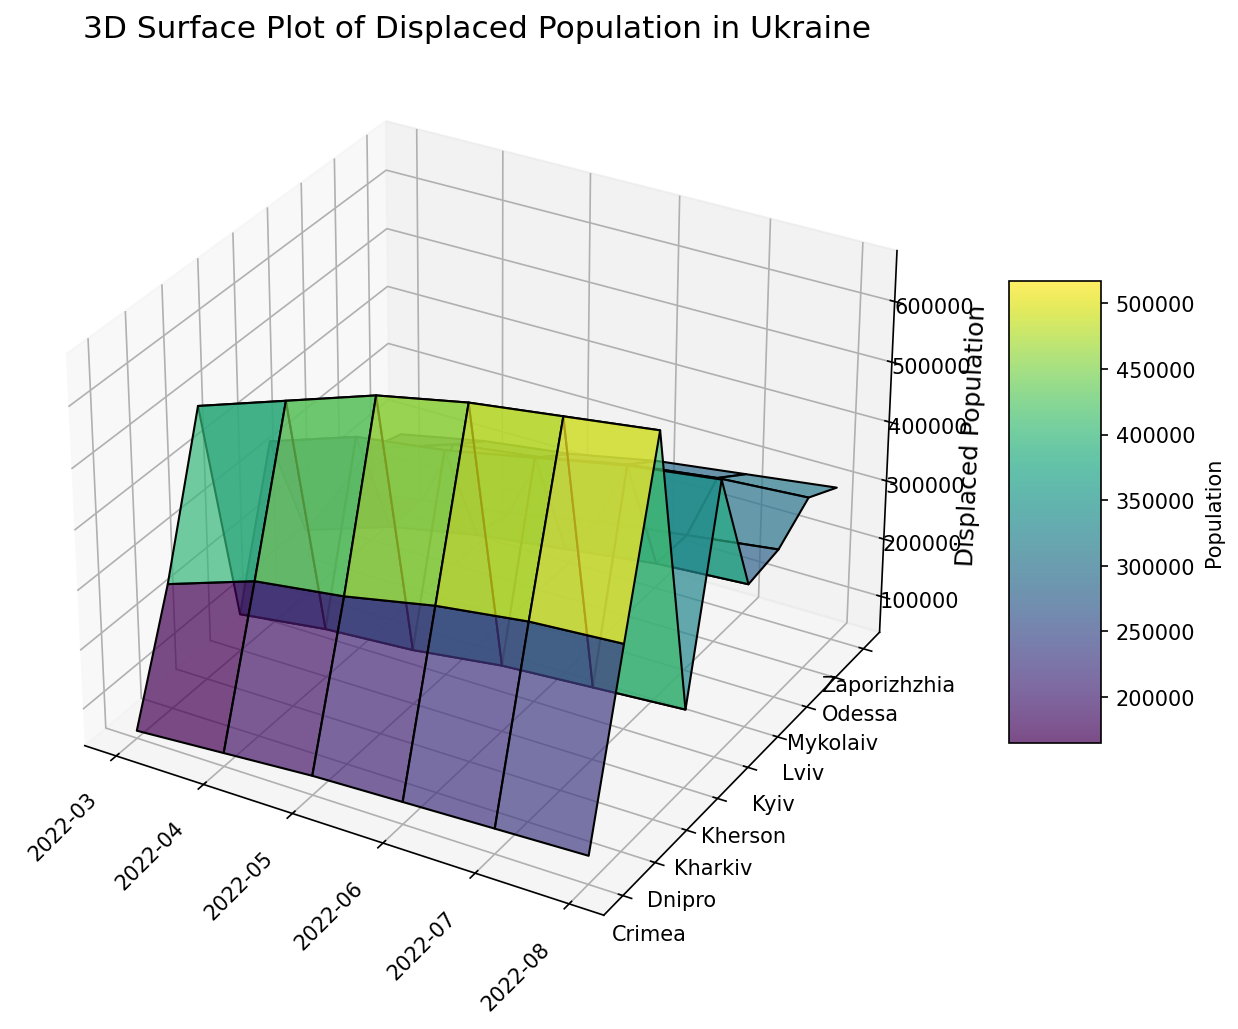Which region had the highest displaced population in August 2022? In the 3D surface plot, look at the highest peak in August 2022. The highest peak is in the Kharkiv region.
Answer: Kharkiv Which region showed the most significant increase in displaced population from March to August 2022? Compare the height differences in the plot for each region from March to August. Kharkiv shows the largest increase, from 500,000 to 670,000.
Answer: Kharkiv What is the average displaced population in Kyiv from March to August 2022? Sum the values for Kyiv from March to August (350,000 + 400,000 + 420,000 + 450,000 + 480,000 + 500,000) and divide by 6. The average is (2,600,000 / 6).
Answer: 433,333 Which two regions had the smallest difference in displaced population in July 2022? Check the heights of the bars for July 2022 and compare the values to find the smallest difference. Zaporizhzhia and Mykolaiv both had minor differences (280,000 and 270,000 respectively).
Answer: Zaporizhzhia and Mykolaiv Which month had the highest total displaced population across all regions? Sum the populations for each region for each month and compare the totals. August 2022 has the highest total displaced population.
Answer: August 2022 In which month did Odessa see the largest month-over-month increase in displaced population? Calculate month-over-month differences for Odessa (250K-200K, 270K-250K, 300K-270K, 320K-300K, 330K-320K) and find the largest. The biggest increase is from March to April.
Answer: April How does the displaced population in Crimea in August 2022 compare to that in Kherson? Compare the heights of the bars for Crimea and Kherson in August 2022. Crimea is at 85,000, while Kherson is at 170,000, so Kherson is higher.
Answer: Kherson is higher What is the total displaced population across all regions in May 2022? Sum the displaced population values for all regions in May 2022 (420,000 + 230,000 + 600,000 + 320,000 + 270,000 + 230,000 + 220,000 + 130,000 + 70,000). The total is 2,490,000.
Answer: 2,490,000 